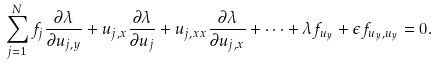<formula> <loc_0><loc_0><loc_500><loc_500>\sum _ { j = 1 } ^ { N } f _ { j } \frac { \partial \lambda } { \partial u _ { j , y } } + u _ { j , x } \frac { \partial \lambda } { \partial u _ { j } } + u _ { j , x x } \frac { \partial \lambda } { \partial u _ { j , x } } + \dots + \lambda f _ { u _ { y } } + \epsilon f _ { u _ { y } , u _ { y } } = 0 .</formula> 